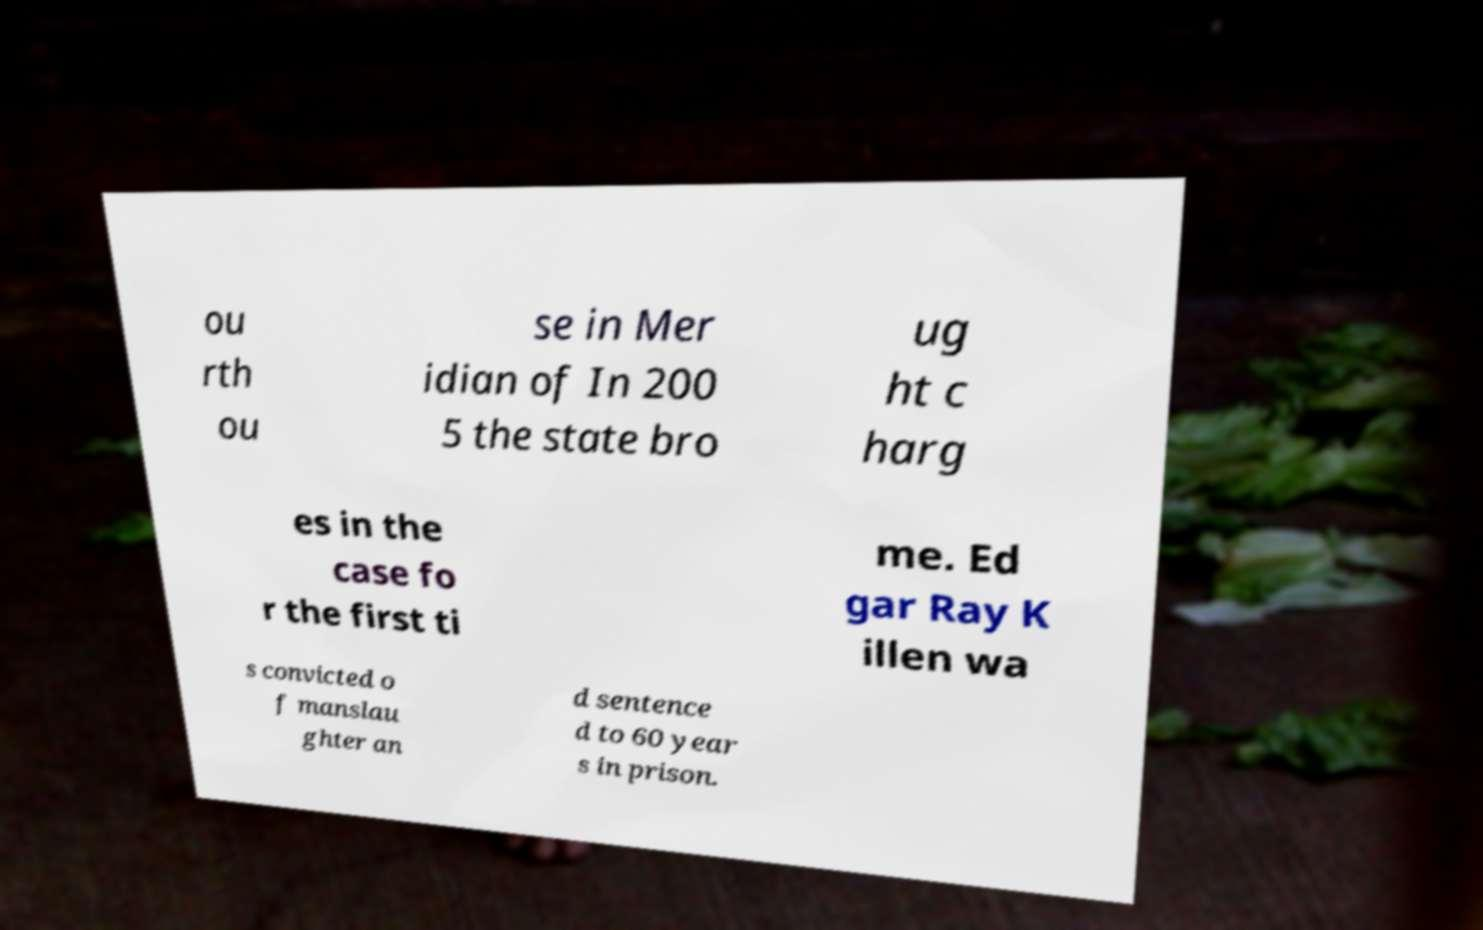Please identify and transcribe the text found in this image. ou rth ou se in Mer idian of In 200 5 the state bro ug ht c harg es in the case fo r the first ti me. Ed gar Ray K illen wa s convicted o f manslau ghter an d sentence d to 60 year s in prison. 